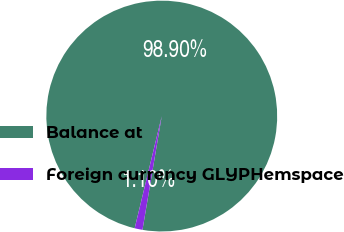Convert chart to OTSL. <chart><loc_0><loc_0><loc_500><loc_500><pie_chart><fcel>Balance at<fcel>Foreign currency GLYPHemspace<nl><fcel>98.9%<fcel>1.1%<nl></chart> 